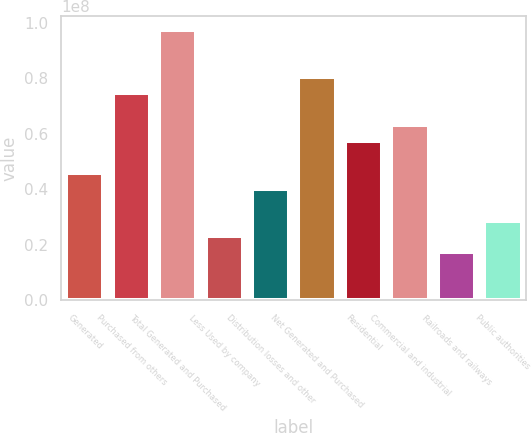Convert chart. <chart><loc_0><loc_0><loc_500><loc_500><bar_chart><fcel>Generated<fcel>Purchased from others<fcel>Total Generated and Purchased<fcel>Less Used by company<fcel>Distribution losses and other<fcel>Net Generated and Purchased<fcel>Residential<fcel>Commercial and industrial<fcel>Railroads and railways<fcel>Public authorities<nl><fcel>4.58689e+07<fcel>7.45369e+07<fcel>9.74713e+07<fcel>2.29344e+07<fcel>4.01353e+07<fcel>8.02705e+07<fcel>5.73361e+07<fcel>6.30697e+07<fcel>1.72008e+07<fcel>2.8668e+07<nl></chart> 